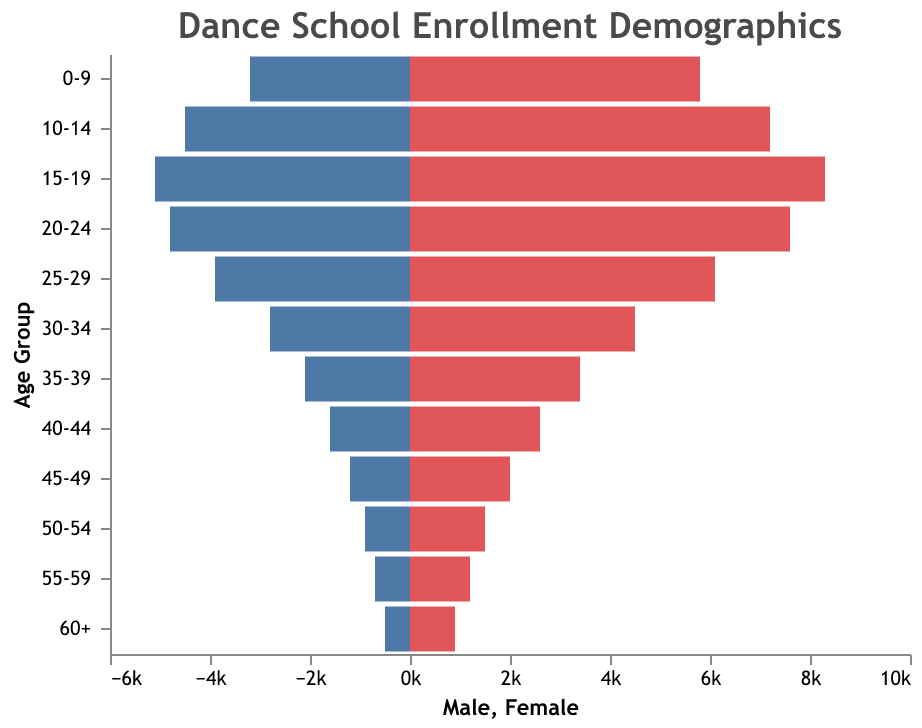What is the title of the figure? The title is positioned at the top and typically provides an overview of what the figure is about. According to the data, the title is "Dance School Enrollment Demographics".
Answer: Dance School Enrollment Demographics Which age group has the highest enrollment for females? The age group with the highest female enrollment is identified by comparing all the female enrollment values. The highest enrollment for females is 8300 in the 15-19 age group.
Answer: 15-19 How many more females are enrolled in the 10-14 age group compared to males? Subtract the number of males enrolled in the 10-14 age group (4500) from the number of females enrolled in the same age group (7200): 7200 - 4500 = 2700.
Answer: 2700 What is the total enrollment for the 20-24 age group? The total enrollment for the 20-24 age group is the sum of male (4800) and female (7600) enrollments: 4800 + 7600 = 12400.
Answer: 12400 In which age group is the difference between male and female enrollment the smallest? By comparing the difference between male and female enrollments across all age groups, the smallest difference is found in the age group 60+ where the difference is 400: 900 - 500 = 400.
Answer: 60+ How does the male enrollment trend as age groups increase from 0-9 to 60+? Observing the pattern of male enrollment values as we move from lower to higher age groups, there is a general decreasing trend. Male enrollments start at 3200 in the 0-9 age group and drop to 500 in the 60+ age group.
Answer: Decreasing Which age group has the lowest total enrollment? Calculate the sum of male and female enrollments for each age group and identify the smallest total. The age group 60+ has the lowest total enrollment with 1400 (900 females + 500 males).
Answer: 60+ How many males are enrolled in the 45-49 age group? According to the data given, the number of males enrolled in the 45-49 age group is 1200.
Answer: 1200 What is the combined enrollment for the 35-39 and 40-44 age groups? Add the total enrollments for both age groups: (2100 males + 3400 females) + (1600 males + 2600 females) = 5500 + 4200 = 9700.
Answer: 9700 Which gender has consistently higher enrollments across all age groups? By comparing male and female enrollments in each age group, it's evident that females consistently have higher enrollments across all age groups.
Answer: Female 